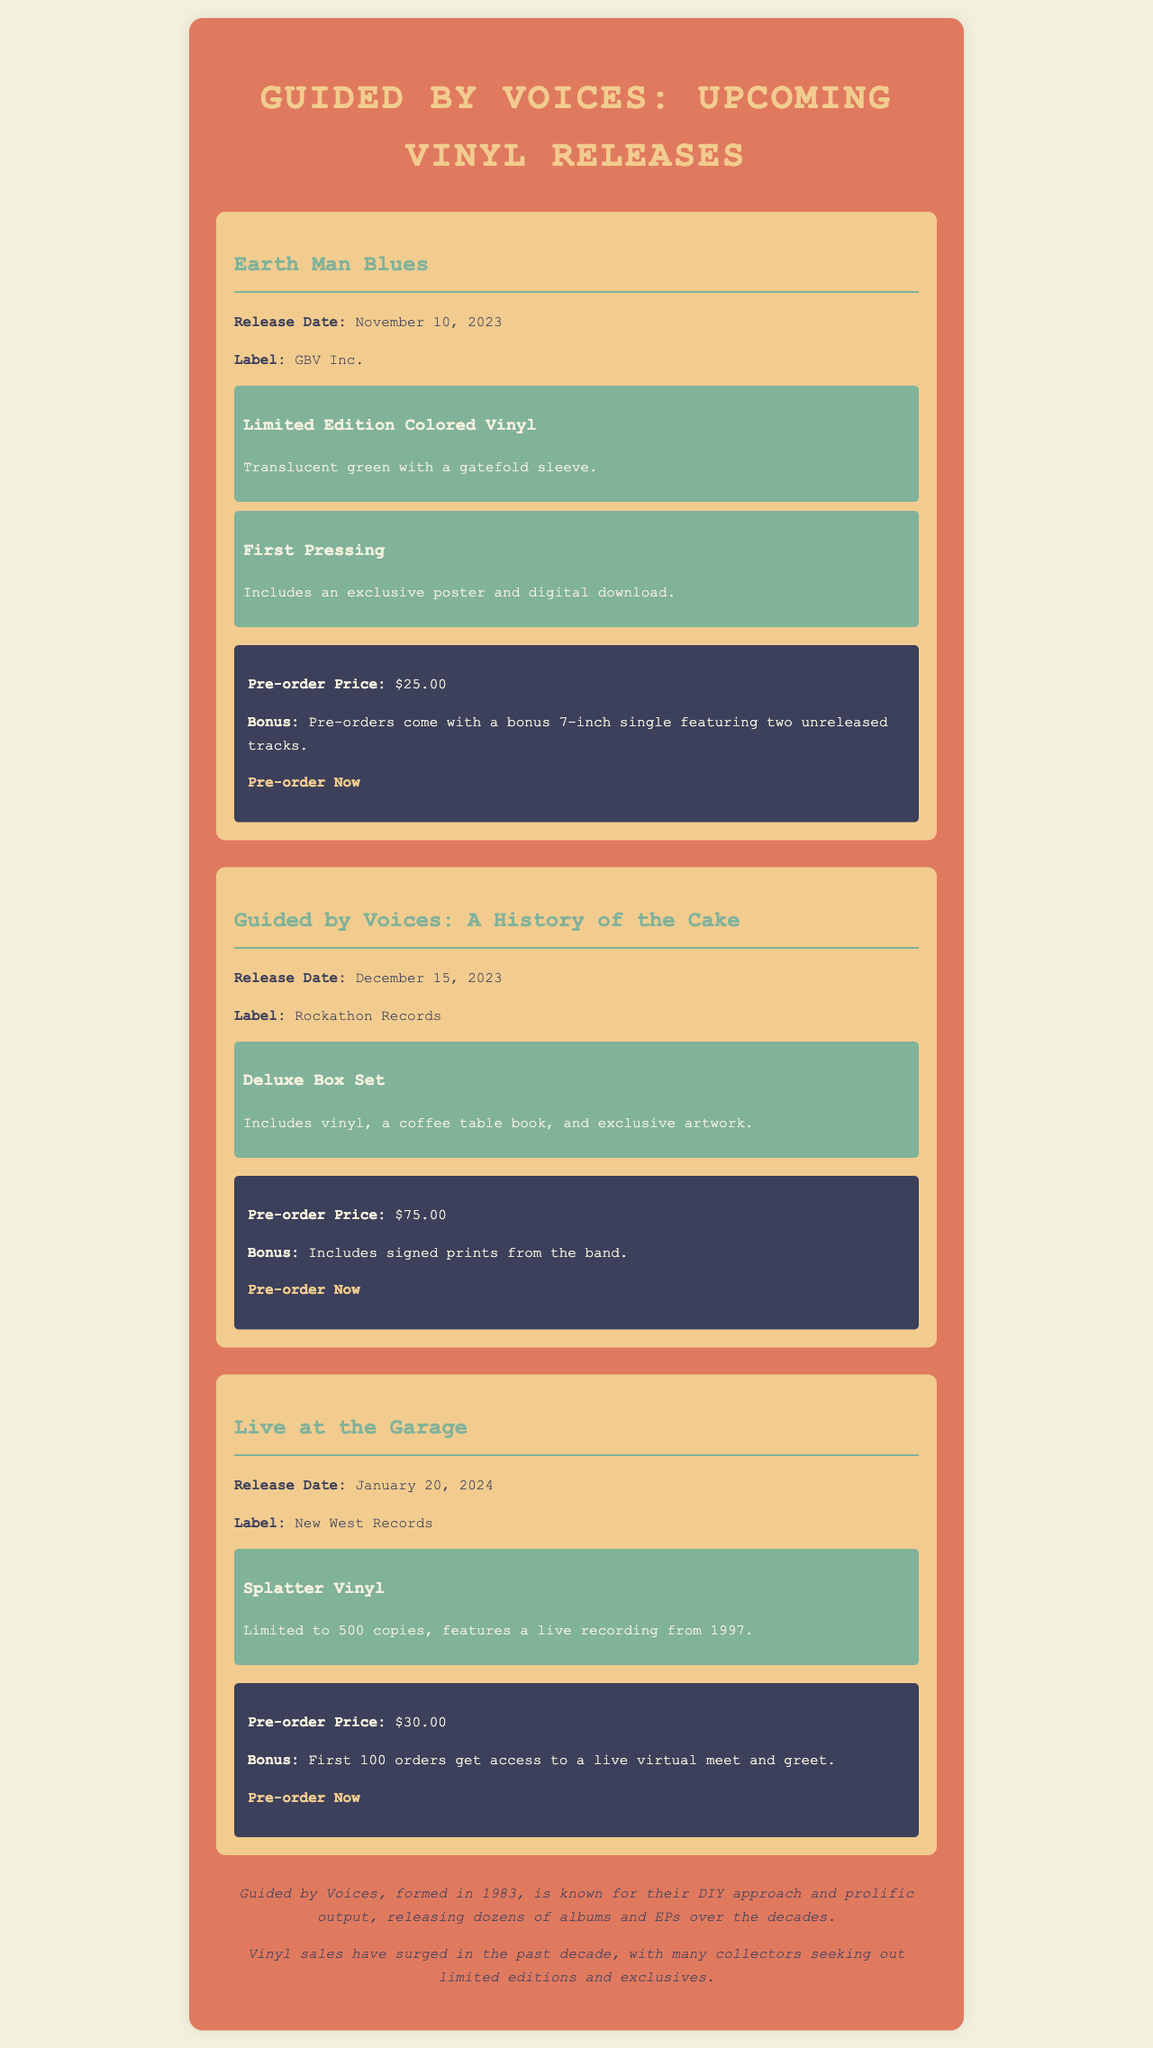What is the release date for "Earth Man Blues"? The release date is explicitly mentioned in the document under the "Earth Man Blues" section.
Answer: November 10, 2023 What is included in the Deluxe Box Set for "Guided by Voices: A History of the Cake"? The document specifies that the Deluxe Box Set includes vinyl, a coffee table book, and exclusive artwork.
Answer: Vinyl, a coffee table book, and exclusive artwork How much is the pre-order price for "Live at the Garage"? The document states the pre-order price for "Live at the Garage" in the corresponding section.
Answer: $30.00 What is the bonus for pre-ordering "Earth Man Blues"? The document mentions the specific bonus associated with pre-orders of this release.
Answer: A bonus 7-inch single featuring two unreleased tracks How many copies of the "Live at the Garage" Splatter Vinyl will be available? The document notes the limitation on the number of copies for this specific edition.
Answer: 500 copies Which label is releasing "Guided by Voices: A History of the Cake"? The label associated with this release is provided in the document under the corresponding section.
Answer: Rockathon Records What is the expected release date for the last vinyl mentioned in the document? The document indicates the release date for "Live at the Garage," which is the last one mentioned.
Answer: January 20, 2024 What is the exclusive feature of the first pressing of "Earth Man Blues"? The document indicates that the first pressing includes an exclusive feature.
Answer: An exclusive poster and digital download What type of vinyl is "Earth Man Blues"? The document describes the type of vinyl specifically for "Earth Man Blues."
Answer: Translucent green with a gatefold sleeve 